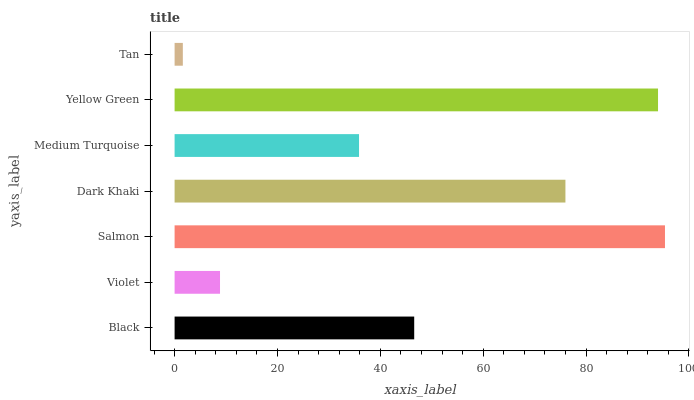Is Tan the minimum?
Answer yes or no. Yes. Is Salmon the maximum?
Answer yes or no. Yes. Is Violet the minimum?
Answer yes or no. No. Is Violet the maximum?
Answer yes or no. No. Is Black greater than Violet?
Answer yes or no. Yes. Is Violet less than Black?
Answer yes or no. Yes. Is Violet greater than Black?
Answer yes or no. No. Is Black less than Violet?
Answer yes or no. No. Is Black the high median?
Answer yes or no. Yes. Is Black the low median?
Answer yes or no. Yes. Is Yellow Green the high median?
Answer yes or no. No. Is Salmon the low median?
Answer yes or no. No. 